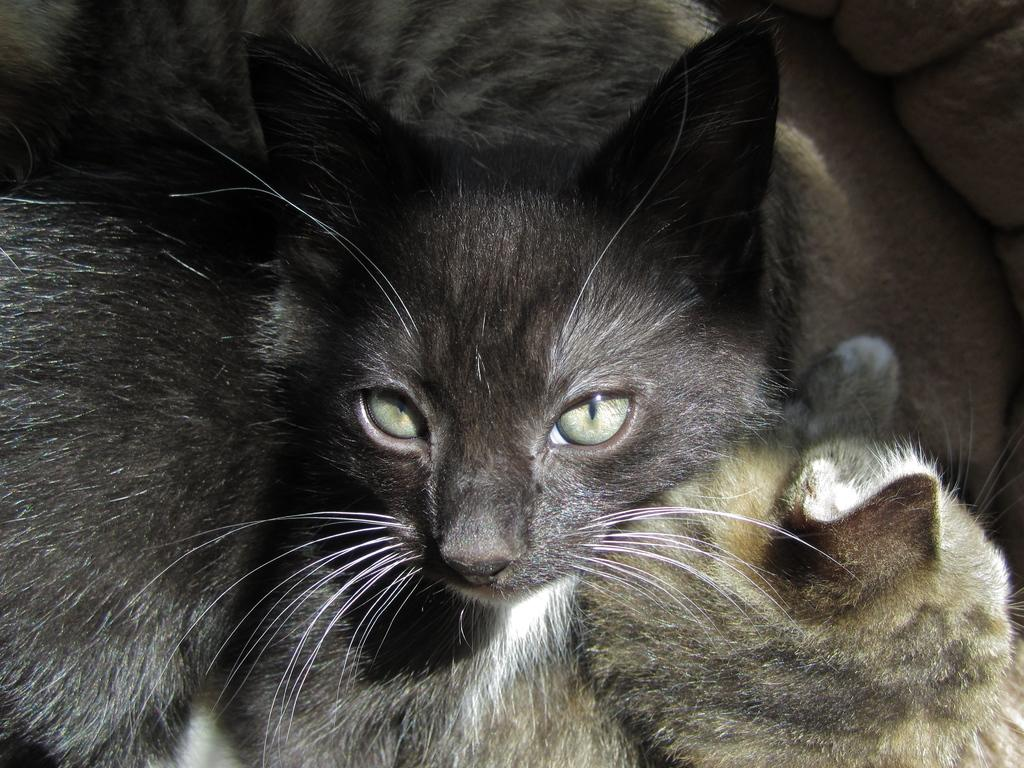How many cats are present in the image? There are two cats in the image. What colors can be seen on the cats? The cats are in black, brown, and white colors. What direction is the flame pointing in the image? There is no flame present in the image. Is there a letter visible in the image? There is no letter visible in the image. 